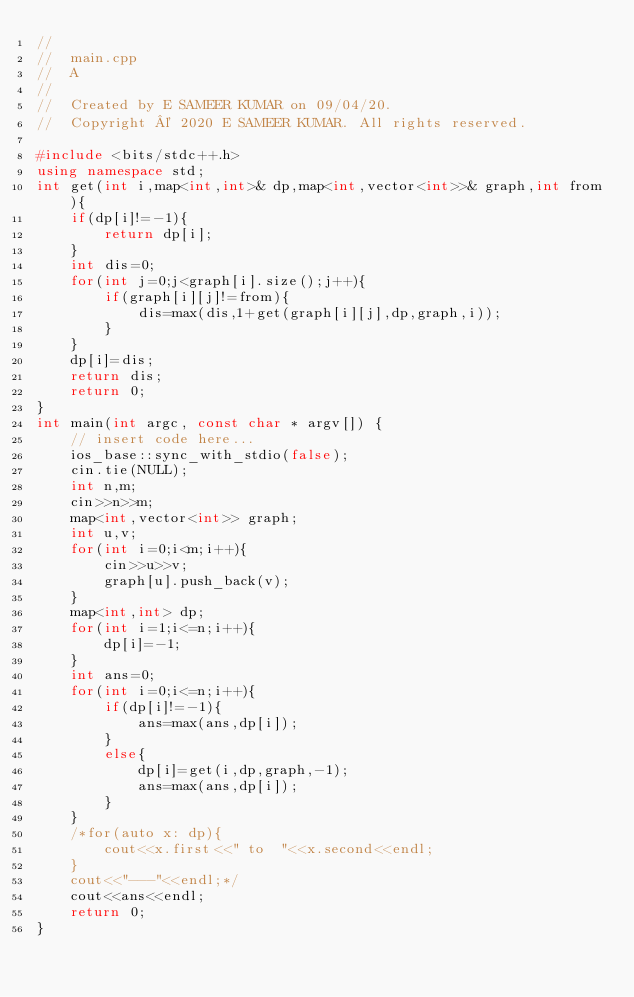<code> <loc_0><loc_0><loc_500><loc_500><_C++_>//
//  main.cpp
//  A
//
//  Created by E SAMEER KUMAR on 09/04/20.
//  Copyright © 2020 E SAMEER KUMAR. All rights reserved.

#include <bits/stdc++.h>
using namespace std;
int get(int i,map<int,int>& dp,map<int,vector<int>>& graph,int from){
    if(dp[i]!=-1){
        return dp[i];
    }
    int dis=0;
    for(int j=0;j<graph[i].size();j++){
        if(graph[i][j]!=from){
            dis=max(dis,1+get(graph[i][j],dp,graph,i));
        }
    }
    dp[i]=dis;
    return dis;
    return 0;
}
int main(int argc, const char * argv[]) {
    // insert code here...
    ios_base::sync_with_stdio(false);
    cin.tie(NULL);
    int n,m;
    cin>>n>>m;
    map<int,vector<int>> graph;
    int u,v;
    for(int i=0;i<m;i++){
        cin>>u>>v;
        graph[u].push_back(v);
    }
    map<int,int> dp;
    for(int i=1;i<=n;i++){
        dp[i]=-1;
    }
    int ans=0;
    for(int i=0;i<=n;i++){
        if(dp[i]!=-1){
            ans=max(ans,dp[i]);
        }
        else{
            dp[i]=get(i,dp,graph,-1);
            ans=max(ans,dp[i]);
        }
    }
    /*for(auto x: dp){
        cout<<x.first<<" to  "<<x.second<<endl;
    }
    cout<<"---"<<endl;*/
    cout<<ans<<endl;
    return 0;
}
</code> 